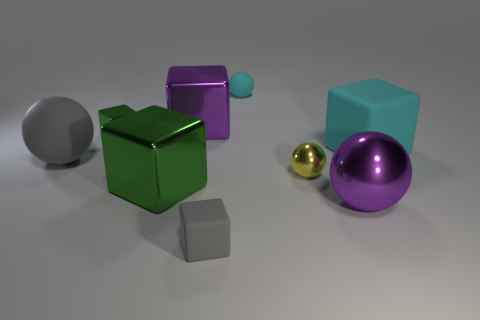Can you tell me the shapes and colors of the objects in the picture? Certainly! The image features a variety of geometric shapes: there is a large cyan cube, a smaller gray cube, a large purple sphere, and a smaller golden sphere. Additionally, there is a big silver sphere and a small cyan sphere. Each object's color is solid and distinct, making them easily discernible from one another. 